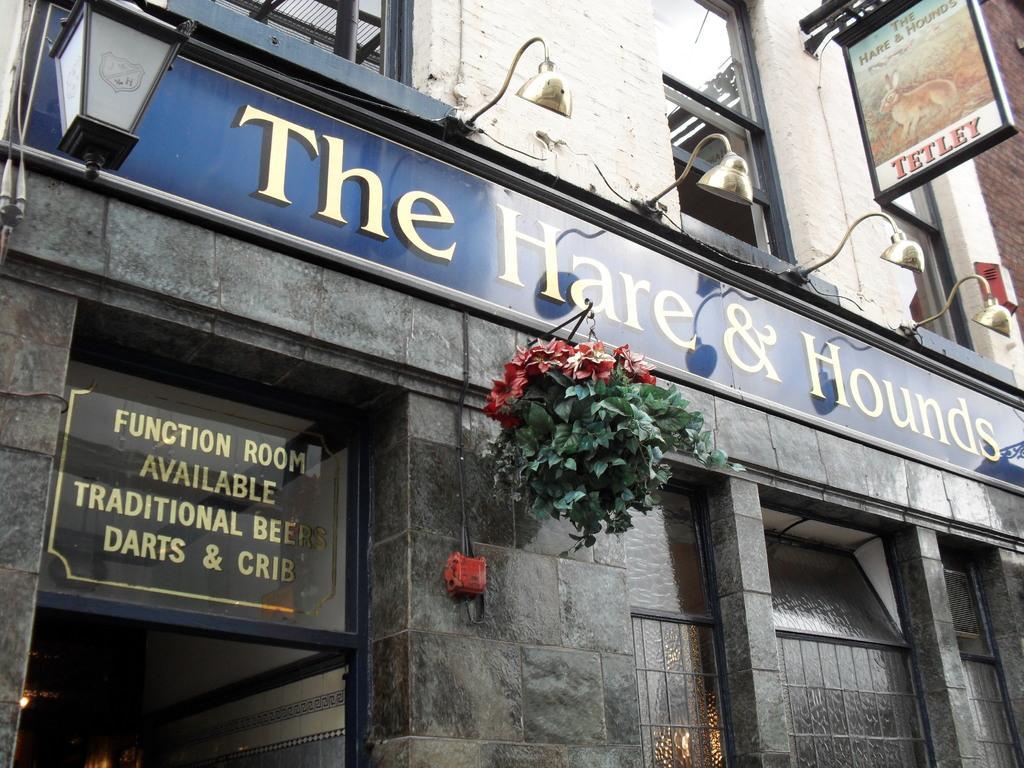Describe this image in one or two sentences. In this picture we can see a building. There are few lights and boards on this building. We can see few windows and a glass on this building. There are some flowers hung to a rod. We can see a lantern on the left side. There is a brick wall on the right side. We can see some lights inside the building. 